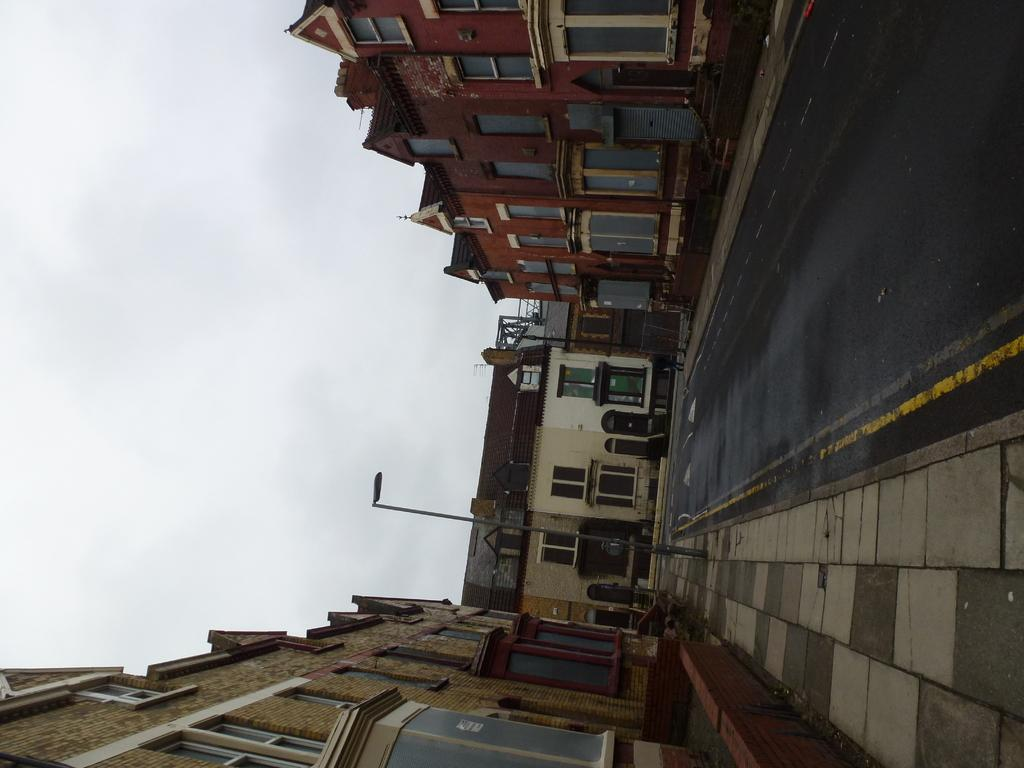What type of structures can be seen in the image? There are buildings in the image. What else is present in the image besides the buildings? There is a road and a light pole in the image. What is the condition of the sky in the image? The sky is cloudy in the image. Can you describe the objects in the image? The objects in the image are not specified, but we know there are buildings, a road, and a light pole. What story is being told by the ice on the buildings in the image? There is no ice on the buildings in the image, so no story can be told by it. What type of system is responsible for the cloudy sky in the image? The provided facts do not mention a system responsible for the cloudy sky; it is simply a weather condition. 